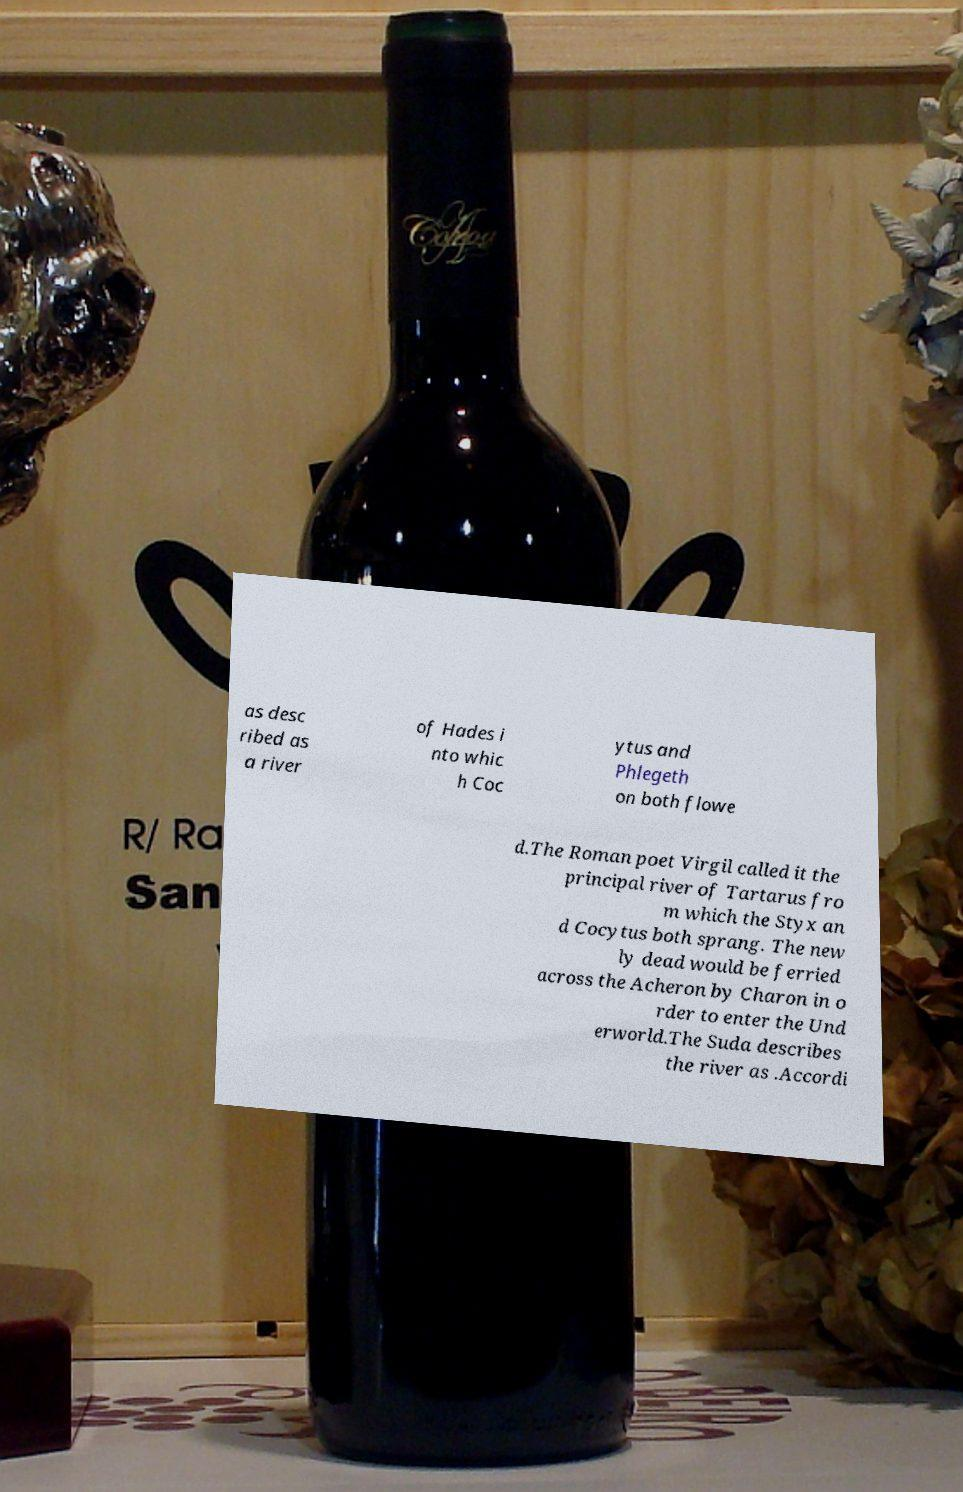Can you accurately transcribe the text from the provided image for me? as desc ribed as a river of Hades i nto whic h Coc ytus and Phlegeth on both flowe d.The Roman poet Virgil called it the principal river of Tartarus fro m which the Styx an d Cocytus both sprang. The new ly dead would be ferried across the Acheron by Charon in o rder to enter the Und erworld.The Suda describes the river as .Accordi 